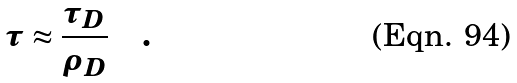Convert formula to latex. <formula><loc_0><loc_0><loc_500><loc_500>\tau \approx \frac { \tau _ { D } } { \rho _ { D } } \quad .</formula> 